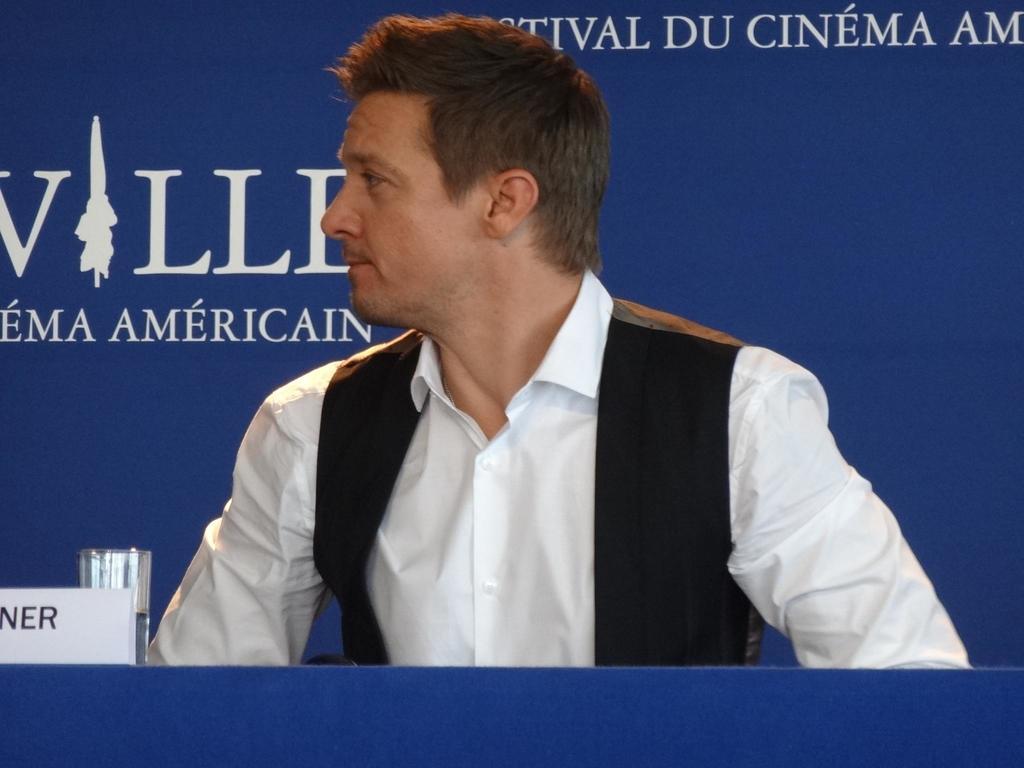Please provide a concise description of this image. There is a man, in front of him we can see glass and name board on the table. In the background we can see hoarding. 